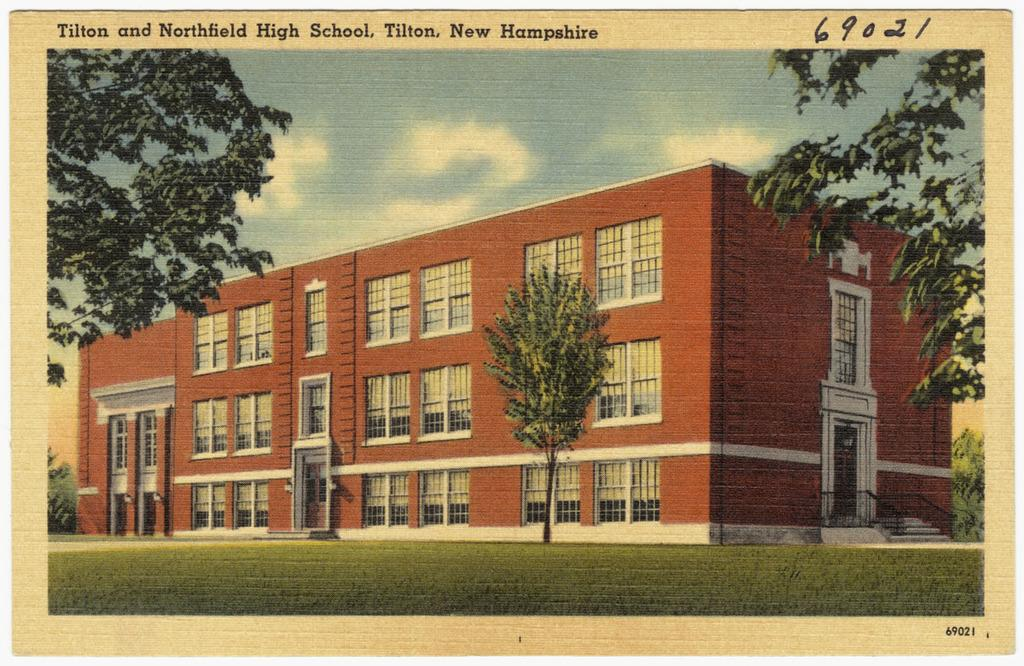What type of natural environment is visible in the image? There is grass in the image, which suggests a natural environment. What type of structure is present in the image? There is a building in the image. What other natural elements can be seen in the image? There are trees in the image. What part of the building can be seen in the image? There are windows in the image, which provide a view of the building's interior. What is visible in the background of the image? The sky is visible in the image. Is there any text present in the image? Yes, there is text in the image. When was the image taken? The image was taken during the day. How many eggs are visible on the building in the image? There are no eggs present on the building in the image. What type of brush is being used to paint the text in the image? There is no brush visible in the image, and the text appears to be printed or written rather than painted. 